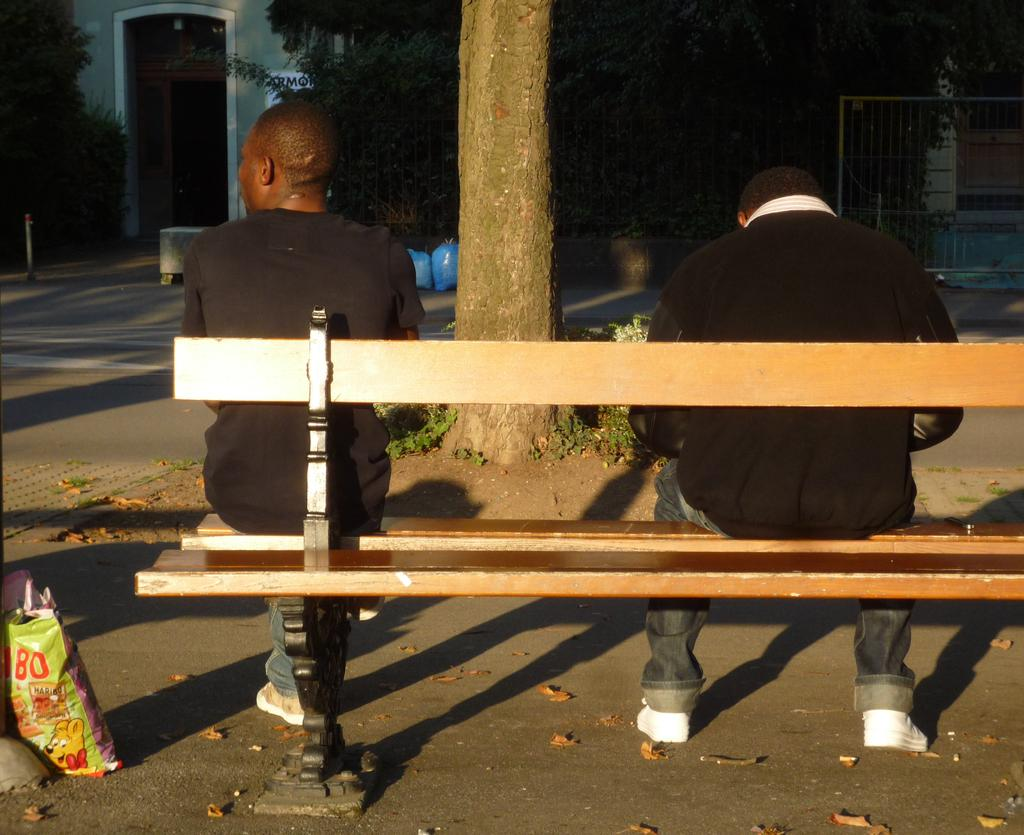Where is the setting of the image? The image is set outside of a city. What are the two persons in the image doing? The two persons are sitting on a bench. What type of footwear are the persons wearing? The persons are wearing shoes. What can be seen in the background of the image? There is a tree, a house, and a gate visible in the background. What type of vein is visible on the persons' hands in the image? There is no visible vein on the persons' hands in the image. What team do the persons in the image belong to? There is no indication of any team affiliation in the image. 